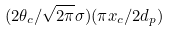Convert formula to latex. <formula><loc_0><loc_0><loc_500><loc_500>( 2 \theta _ { c } / \sqrt { 2 \pi } \sigma ) ( \pi x _ { c } / 2 d _ { p } )</formula> 